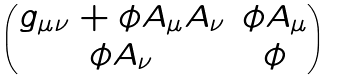<formula> <loc_0><loc_0><loc_500><loc_500>\begin{pmatrix} g _ { \mu \nu } + \phi A _ { \mu } A _ { \nu } & \phi A _ { \mu } \\ \phi A _ { \nu } & \phi \end{pmatrix}</formula> 